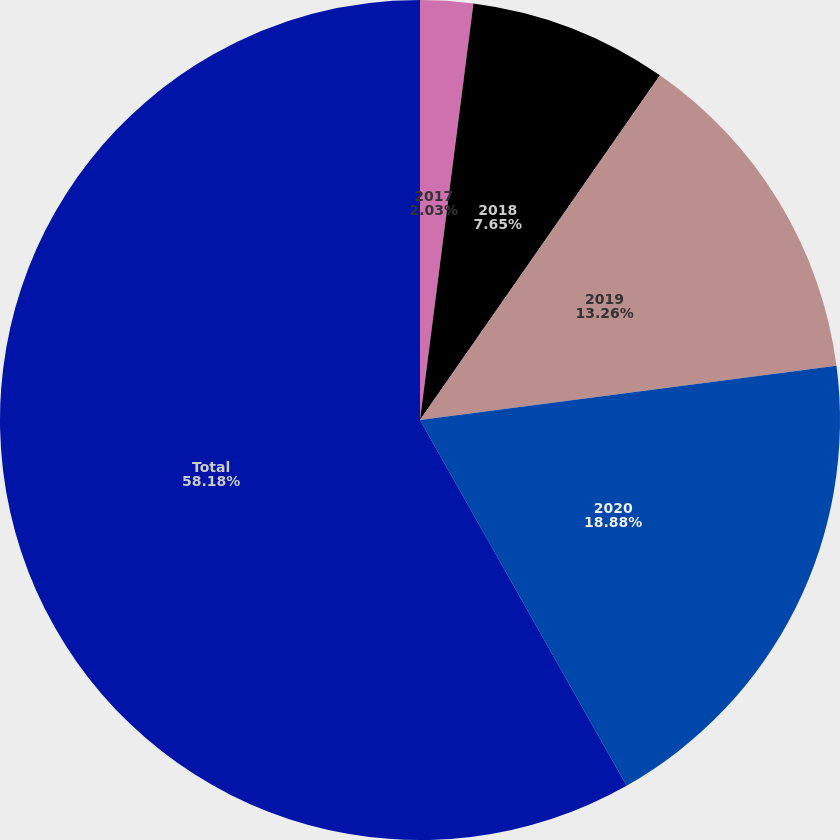Convert chart to OTSL. <chart><loc_0><loc_0><loc_500><loc_500><pie_chart><fcel>2017<fcel>2018<fcel>2019<fcel>2020<fcel>Total<nl><fcel>2.03%<fcel>7.65%<fcel>13.26%<fcel>18.88%<fcel>58.19%<nl></chart> 